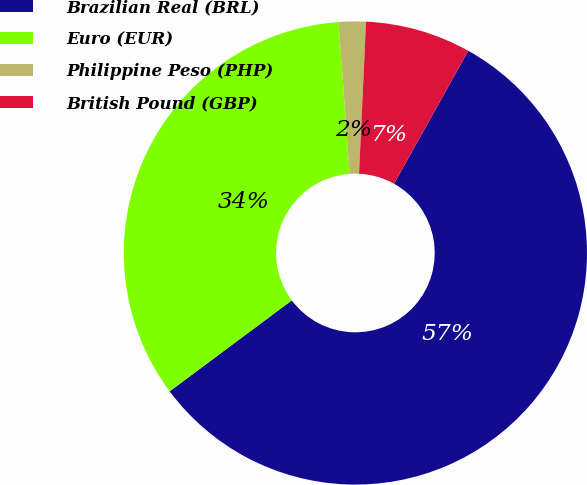Convert chart. <chart><loc_0><loc_0><loc_500><loc_500><pie_chart><fcel>Brazilian Real (BRL)<fcel>Euro (EUR)<fcel>Philippine Peso (PHP)<fcel>British Pound (GBP)<nl><fcel>56.71%<fcel>34.03%<fcel>1.89%<fcel>7.37%<nl></chart> 